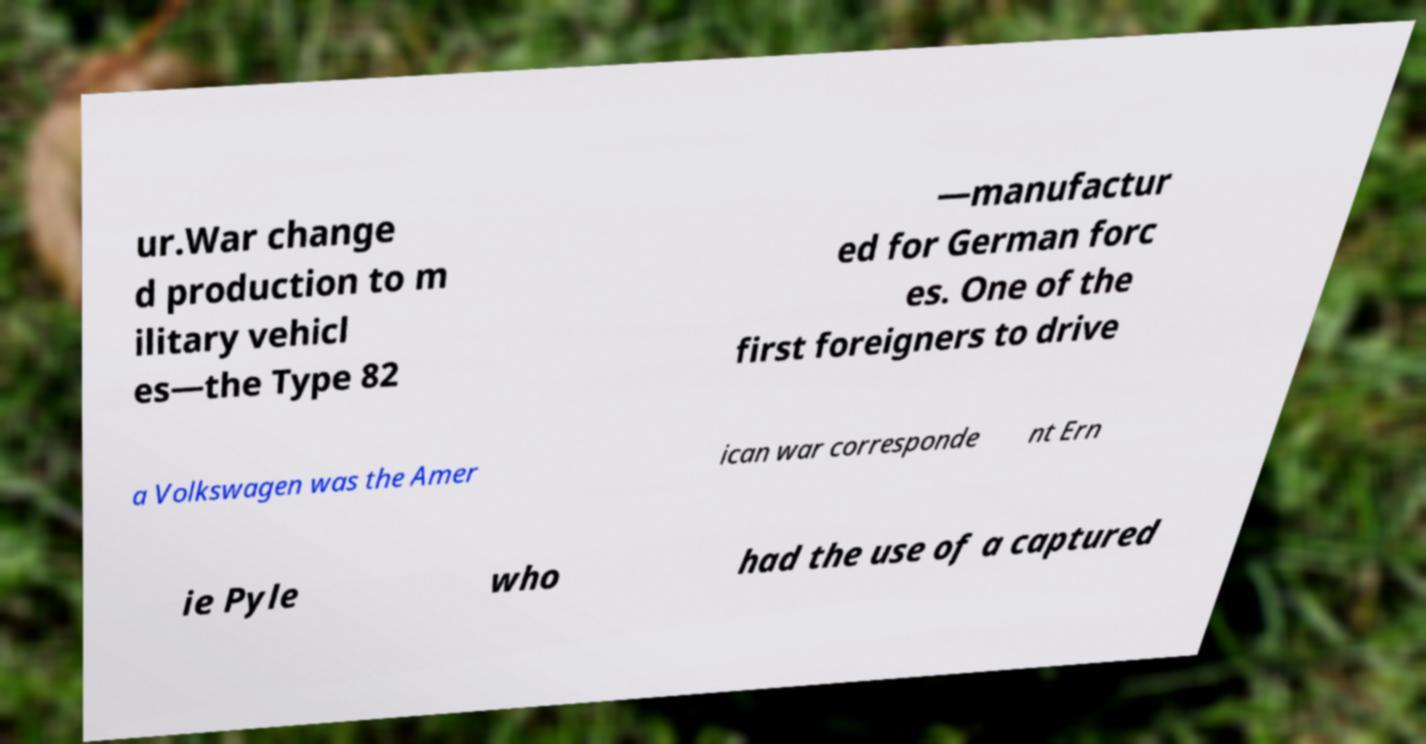Can you accurately transcribe the text from the provided image for me? ur.War change d production to m ilitary vehicl es—the Type 82 —manufactur ed for German forc es. One of the first foreigners to drive a Volkswagen was the Amer ican war corresponde nt Ern ie Pyle who had the use of a captured 